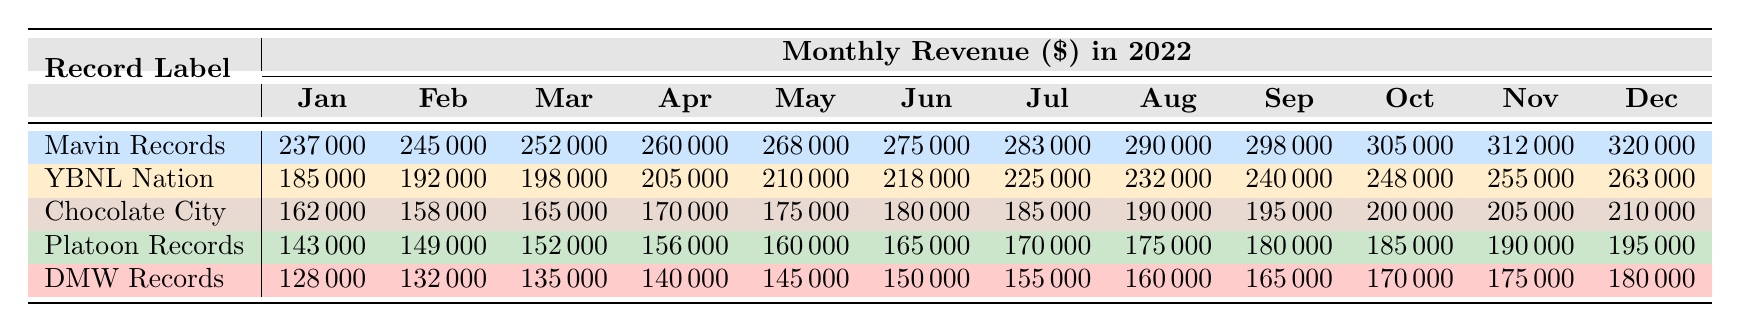What was the highest monthly revenue for Mavin Records in 2022? The revenue for Mavin Records in December is the highest recorded at 320,000.
Answer: 320000 In which month did YBNL Nation have the lowest revenue? The lowest revenue for YBNL Nation occurred in January at 185,000.
Answer: 185000 What is the total revenue of Chocolate City for the year 2022? By summing the monthly revenues of Chocolate City (162,000 + 158,000 + 165,000 + 170,000 + 175,000 + 180,000 + 185,000 + 190,000 + 195,000 + 200,000 + 205,000 + 210,000), we get 2,144,000.
Answer: 2144000 Did Platoon Records ever exceed 180,000 in revenue during 2022? Yes, Platoon Records exceeded 180,000 starting from July to December, with revenues of 170,000 and it went up to 195,000.
Answer: Yes What was the average monthly revenue for DMW Records over the year 2022? To find the average, sum DMW's monthly revenues (128,000 + 132,000 + 135,000 + 140,000 + 145,000 + 150,000 + 155,000 + 160,000 + 165,000 + 170,000 + 175,000 + 180,000) totaling 1,735,000, and divide by 12, resulting in 144,583.33, which rounds to approximately 144,583.
Answer: 144583 Which record label had the highest revenue in October 2022? In October, Mavin Records had the highest revenue at 305,000 compared to YBNL Nation at 248,000, Chocolate City at 200,000, Platoon Records at 185,000, and DMW Records at 170,000.
Answer: Mavin Records What was the percentage increase in revenue for YBNL Nation from January to December? The revenue increased from 185,000 in January to 263,000 in December. The increase is 263,000 - 185,000 = 78,000, and the percentage increase is (78,000 / 185,000) * 100 which is approximately 42.16%.
Answer: Approximately 42.16% Which record label consistently had the lowest revenue each month throughout 2022? DMW Records had the lowest revenue every month, starting from 128,000 in January to 180,000 in December.
Answer: DMW Records What was the difference in revenue between Mavin Records and YBNL Nation in November? In November, Mavin Records had 312,000 and YBNL Nation had 255,000, resulting in a difference of 312,000 - 255,000 = 57,000.
Answer: 57000 How many months did Chocolate City have revenue above 180,000? Chocolate City had revenue above 180,000 in March (185,000), April (170,000), May (175,000), June (180,000), July (185,000), August (190,000), September (195,000), October (200,000), November (205,000), and December (210,000), totaling 10 months.
Answer: 10 